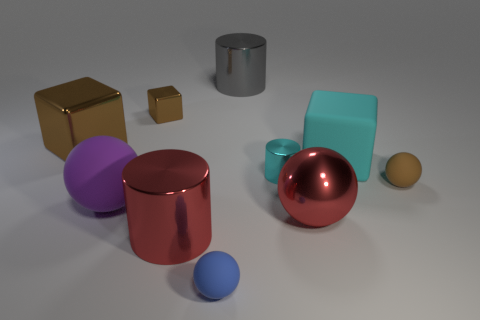The other big cylinder that is made of the same material as the big red cylinder is what color?
Your answer should be compact. Gray. What material is the tiny brown object to the right of the gray metallic thing?
Your answer should be compact. Rubber. There is a large gray metal object; does it have the same shape as the red object that is on the left side of the blue matte object?
Offer a terse response. Yes. What is the cylinder that is behind the brown ball and in front of the cyan cube made of?
Provide a succinct answer. Metal. What color is the metal sphere that is the same size as the purple object?
Your response must be concise. Red. Is the red ball made of the same material as the tiny brown thing that is behind the big cyan rubber thing?
Offer a very short reply. Yes. How many other things are the same size as the blue object?
Provide a succinct answer. 3. There is a brown shiny block right of the big sphere that is on the left side of the large gray object; is there a big red thing that is on the right side of it?
Provide a short and direct response. Yes. The brown sphere is what size?
Provide a succinct answer. Small. There is a cylinder to the right of the gray cylinder; what is its size?
Your response must be concise. Small. 